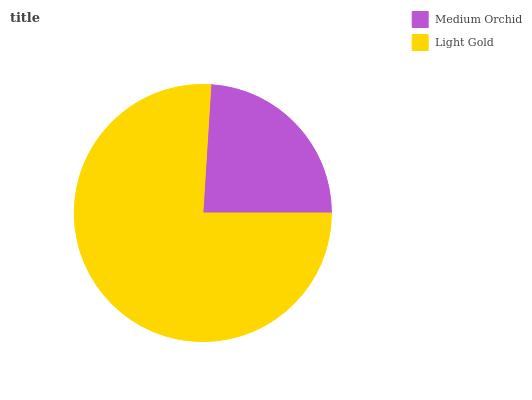Is Medium Orchid the minimum?
Answer yes or no. Yes. Is Light Gold the maximum?
Answer yes or no. Yes. Is Light Gold the minimum?
Answer yes or no. No. Is Light Gold greater than Medium Orchid?
Answer yes or no. Yes. Is Medium Orchid less than Light Gold?
Answer yes or no. Yes. Is Medium Orchid greater than Light Gold?
Answer yes or no. No. Is Light Gold less than Medium Orchid?
Answer yes or no. No. Is Light Gold the high median?
Answer yes or no. Yes. Is Medium Orchid the low median?
Answer yes or no. Yes. Is Medium Orchid the high median?
Answer yes or no. No. Is Light Gold the low median?
Answer yes or no. No. 